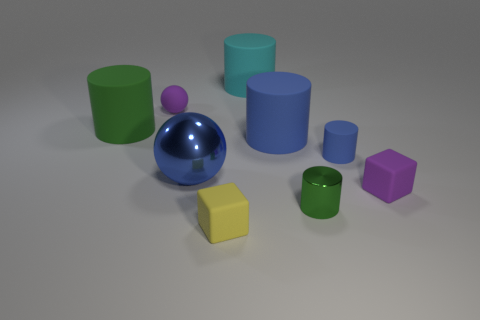Subtract 2 cylinders. How many cylinders are left? 3 Add 1 large blue balls. How many objects exist? 10 Subtract all spheres. How many objects are left? 7 Subtract all gray cylinders. Subtract all tiny rubber cylinders. How many objects are left? 8 Add 7 large rubber objects. How many large rubber objects are left? 10 Add 6 big purple rubber cubes. How many big purple rubber cubes exist? 6 Subtract 1 purple blocks. How many objects are left? 8 